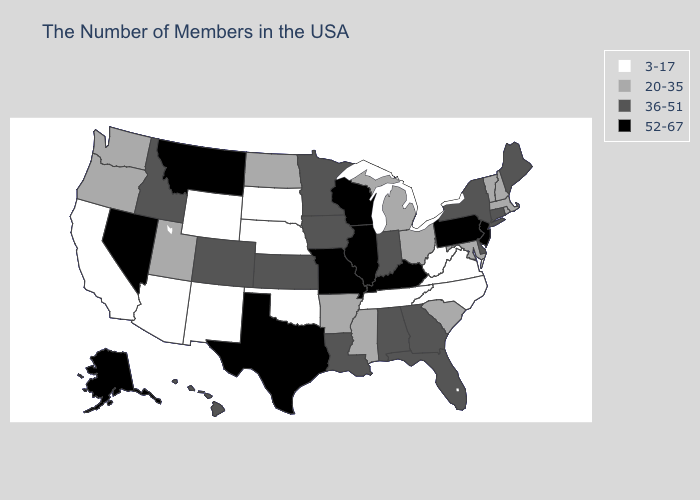Among the states that border Texas , which have the lowest value?
Quick response, please. Oklahoma, New Mexico. Among the states that border Indiana , does Illinois have the lowest value?
Short answer required. No. Does the first symbol in the legend represent the smallest category?
Give a very brief answer. Yes. Name the states that have a value in the range 36-51?
Concise answer only. Maine, Connecticut, New York, Delaware, Florida, Georgia, Indiana, Alabama, Louisiana, Minnesota, Iowa, Kansas, Colorado, Idaho, Hawaii. What is the value of Michigan?
Write a very short answer. 20-35. Does Pennsylvania have the highest value in the USA?
Keep it brief. Yes. What is the highest value in the MidWest ?
Answer briefly. 52-67. Does Michigan have the same value as Arizona?
Answer briefly. No. What is the value of Missouri?
Quick response, please. 52-67. What is the highest value in states that border Idaho?
Concise answer only. 52-67. Name the states that have a value in the range 20-35?
Concise answer only. Massachusetts, Rhode Island, New Hampshire, Vermont, Maryland, South Carolina, Ohio, Michigan, Mississippi, Arkansas, North Dakota, Utah, Washington, Oregon. What is the highest value in the MidWest ?
Keep it brief. 52-67. What is the lowest value in states that border New York?
Be succinct. 20-35. Name the states that have a value in the range 36-51?
Write a very short answer. Maine, Connecticut, New York, Delaware, Florida, Georgia, Indiana, Alabama, Louisiana, Minnesota, Iowa, Kansas, Colorado, Idaho, Hawaii. Which states have the lowest value in the USA?
Keep it brief. Virginia, North Carolina, West Virginia, Tennessee, Nebraska, Oklahoma, South Dakota, Wyoming, New Mexico, Arizona, California. 